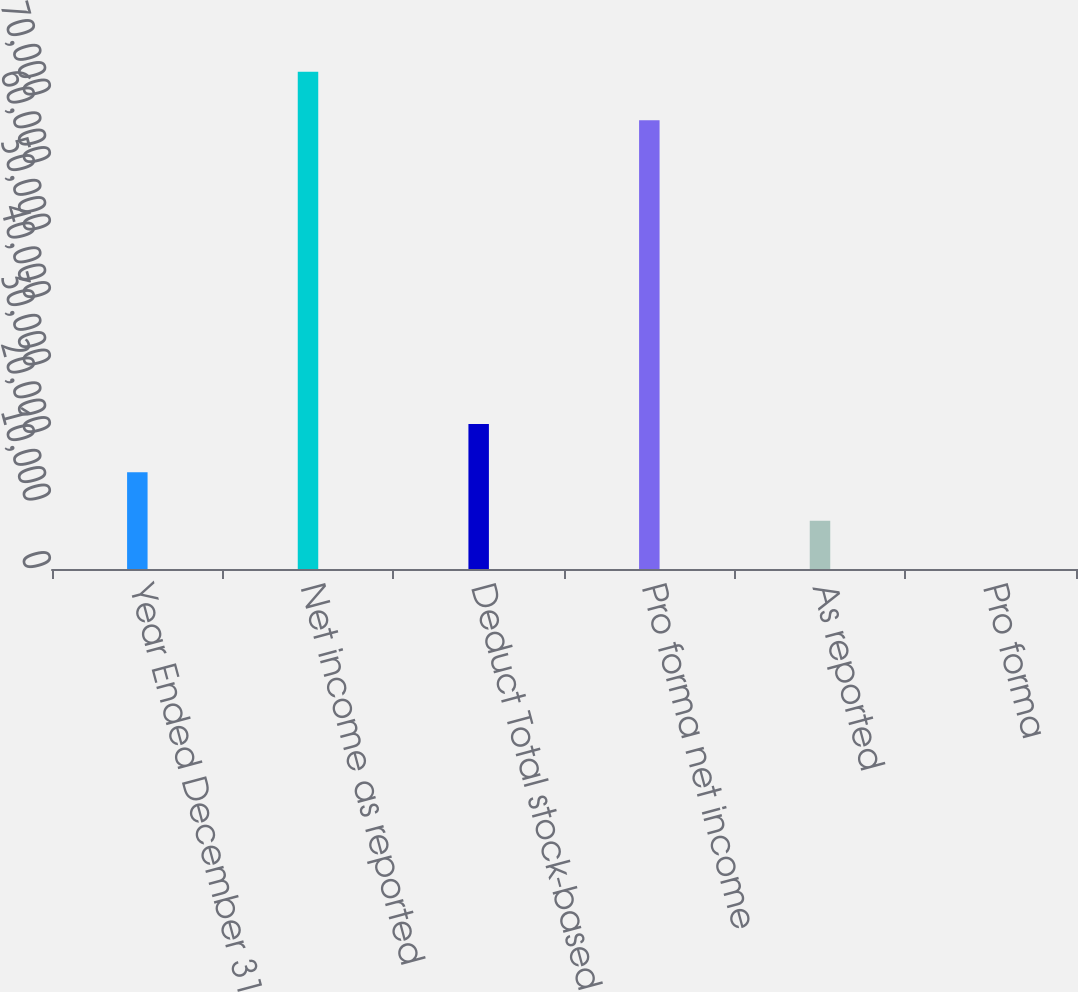Convert chart to OTSL. <chart><loc_0><loc_0><loc_500><loc_500><bar_chart><fcel>Year Ended December 31<fcel>Net income as reported<fcel>Deduct Total stock-based<fcel>Pro forma net income<fcel>As reported<fcel>Pro forma<nl><fcel>14320.1<fcel>73652.4<fcel>21479.5<fcel>66493<fcel>7160.79<fcel>1.43<nl></chart> 